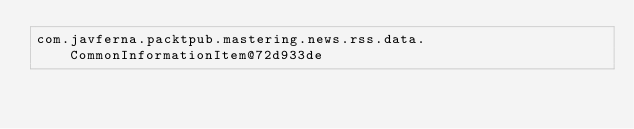Convert code to text. <code><loc_0><loc_0><loc_500><loc_500><_XML_>com.javferna.packtpub.mastering.news.rss.data.CommonInformationItem@72d933de</code> 